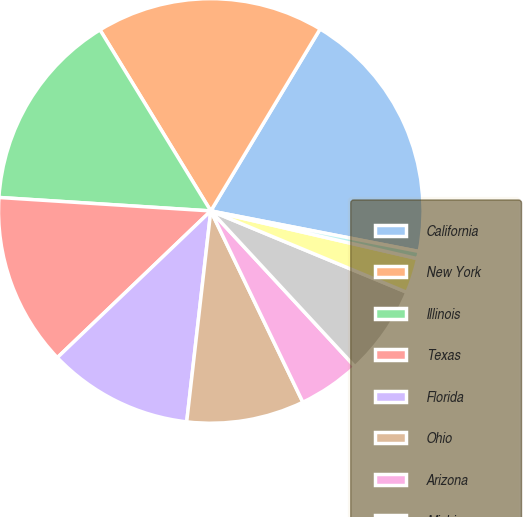Convert chart to OTSL. <chart><loc_0><loc_0><loc_500><loc_500><pie_chart><fcel>California<fcel>New York<fcel>Illinois<fcel>Texas<fcel>Florida<fcel>Ohio<fcel>Arizona<fcel>Michigan<fcel>New Jersey<fcel>Colorado<nl><fcel>19.45%<fcel>17.35%<fcel>15.25%<fcel>13.15%<fcel>11.05%<fcel>8.95%<fcel>4.75%<fcel>6.85%<fcel>2.65%<fcel>0.55%<nl></chart> 